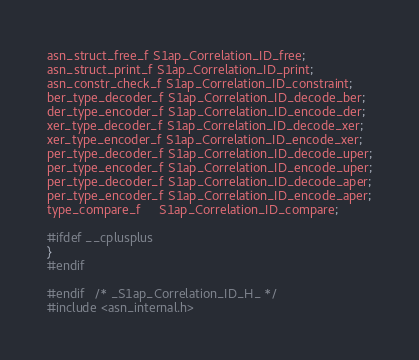Convert code to text. <code><loc_0><loc_0><loc_500><loc_500><_C_>asn_struct_free_f S1ap_Correlation_ID_free;
asn_struct_print_f S1ap_Correlation_ID_print;
asn_constr_check_f S1ap_Correlation_ID_constraint;
ber_type_decoder_f S1ap_Correlation_ID_decode_ber;
der_type_encoder_f S1ap_Correlation_ID_encode_der;
xer_type_decoder_f S1ap_Correlation_ID_decode_xer;
xer_type_encoder_f S1ap_Correlation_ID_encode_xer;
per_type_decoder_f S1ap_Correlation_ID_decode_uper;
per_type_encoder_f S1ap_Correlation_ID_encode_uper;
per_type_decoder_f S1ap_Correlation_ID_decode_aper;
per_type_encoder_f S1ap_Correlation_ID_encode_aper;
type_compare_f     S1ap_Correlation_ID_compare;

#ifdef __cplusplus
}
#endif

#endif	/* _S1ap_Correlation_ID_H_ */
#include <asn_internal.h>
</code> 